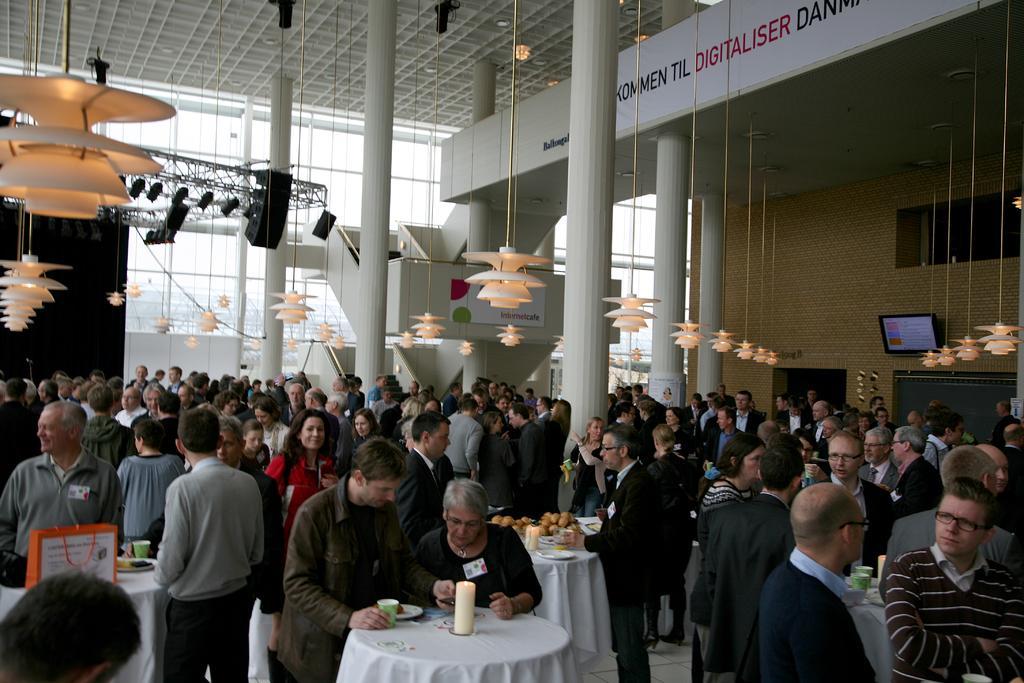Please provide a concise description of this image. As we can see in the image there is a wall, screen, windows, lights, few people here and there and there are tables. On table there is a candle, plate, glass and fruits. 